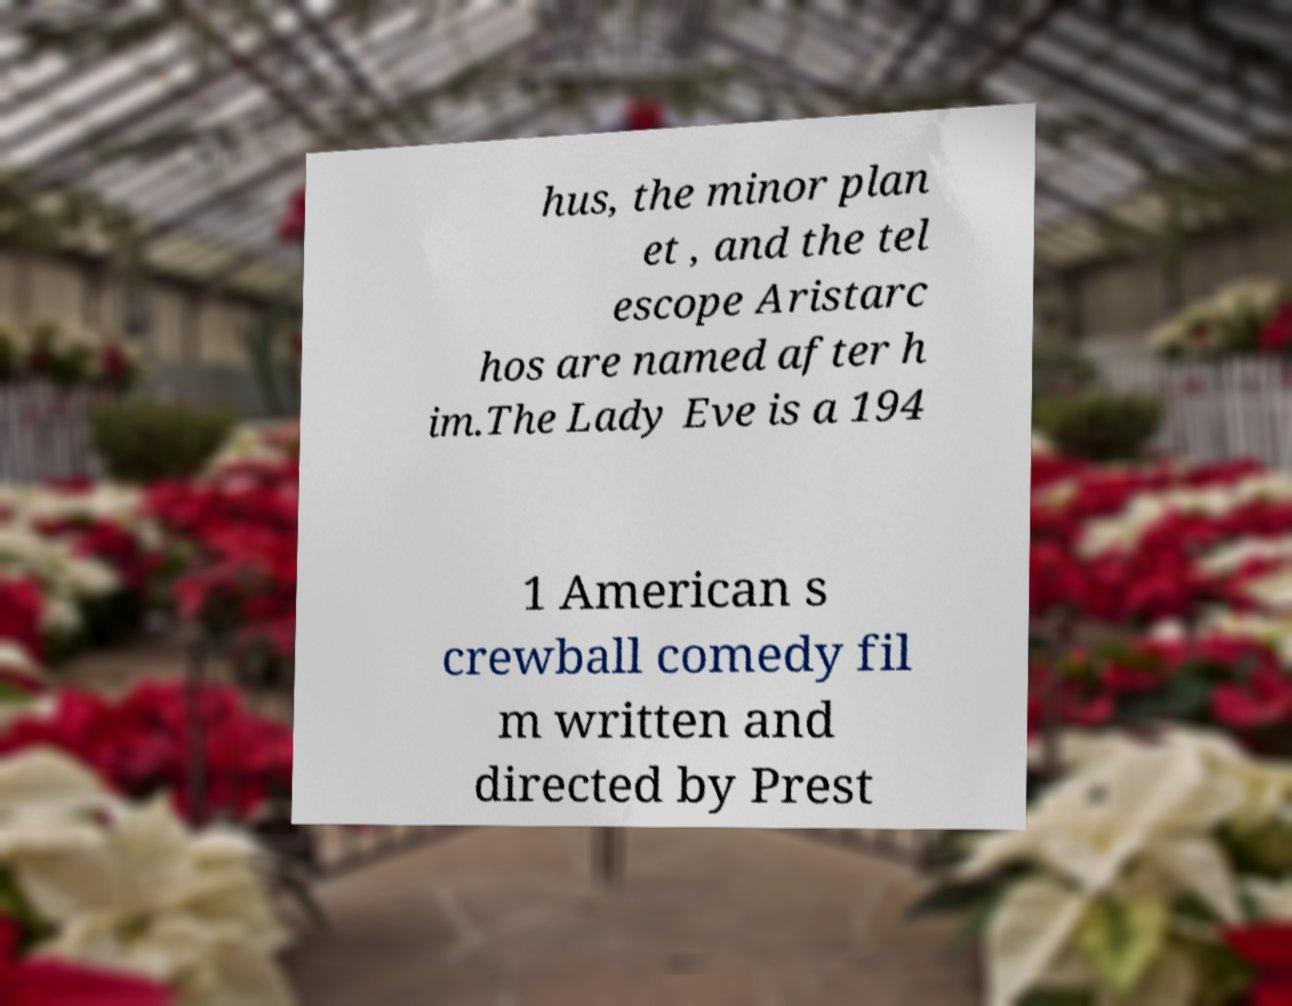Please read and relay the text visible in this image. What does it say? hus, the minor plan et , and the tel escope Aristarc hos are named after h im.The Lady Eve is a 194 1 American s crewball comedy fil m written and directed by Prest 